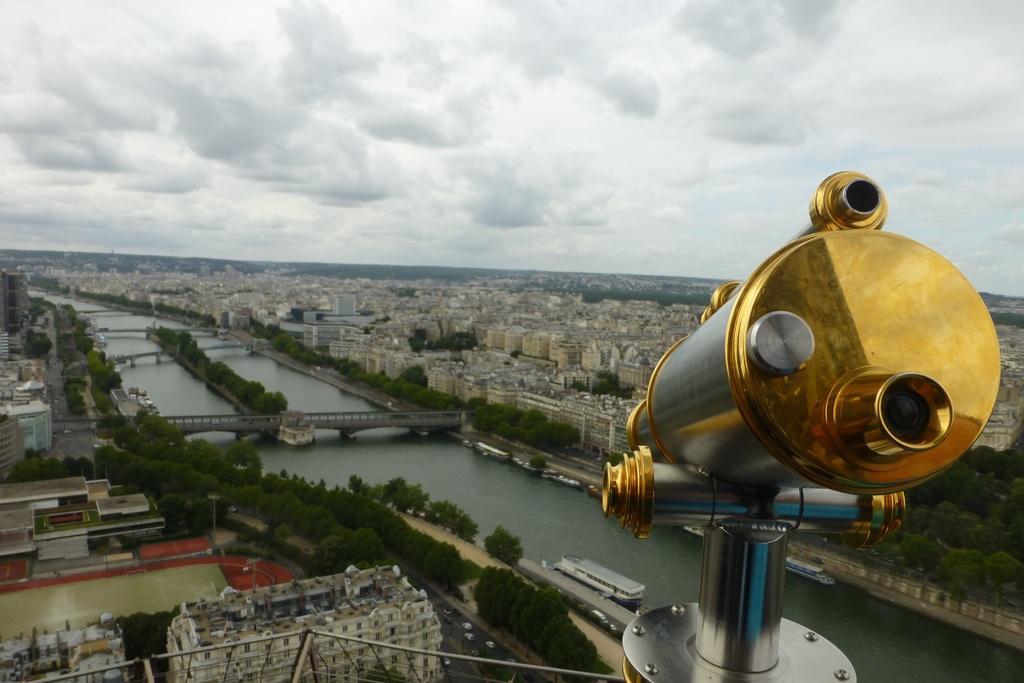Can you describe this image briefly? This is an aerial view and here we can see buildings, trees, bridges and we can see a tower and there are boats on the water. At the top, there are clouds in the sky. 